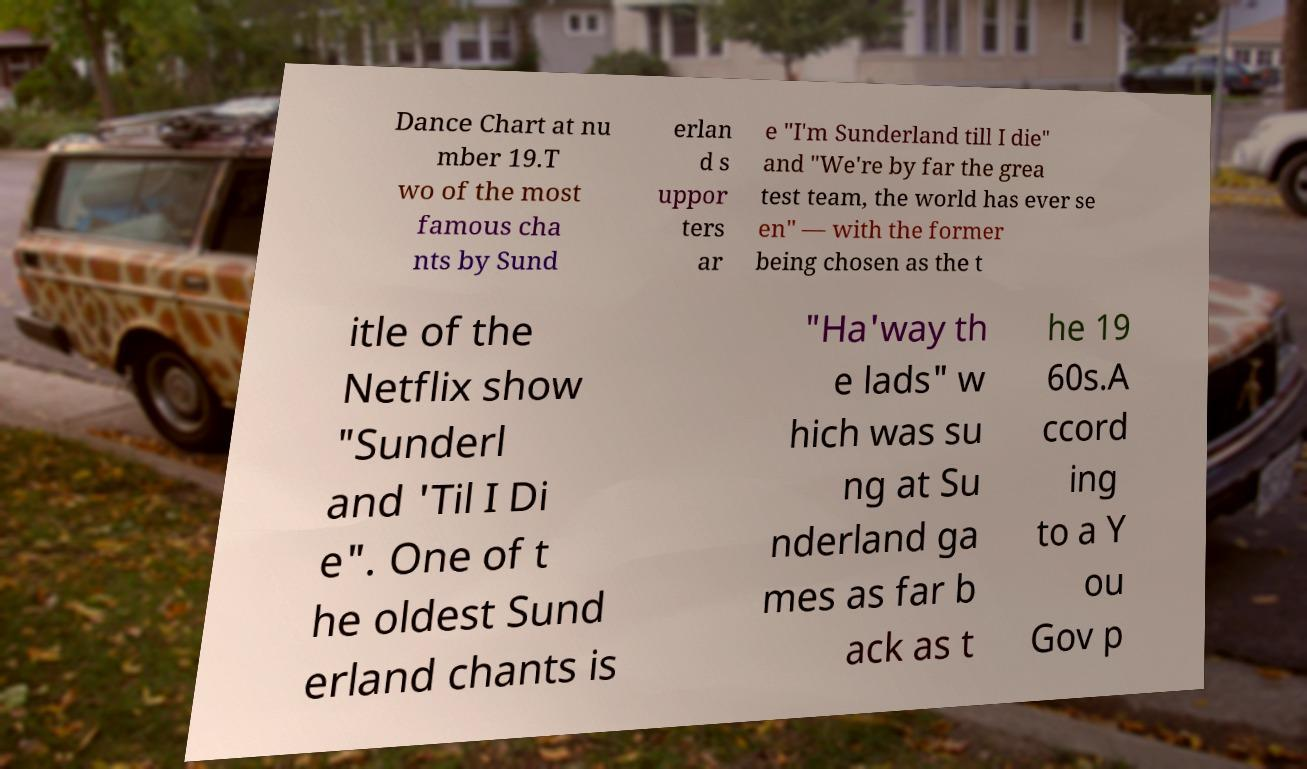For documentation purposes, I need the text within this image transcribed. Could you provide that? Dance Chart at nu mber 19.T wo of the most famous cha nts by Sund erlan d s uppor ters ar e "I'm Sunderland till I die" and "We're by far the grea test team, the world has ever se en" — with the former being chosen as the t itle of the Netflix show "Sunderl and 'Til I Di e". One of t he oldest Sund erland chants is "Ha'way th e lads" w hich was su ng at Su nderland ga mes as far b ack as t he 19 60s.A ccord ing to a Y ou Gov p 